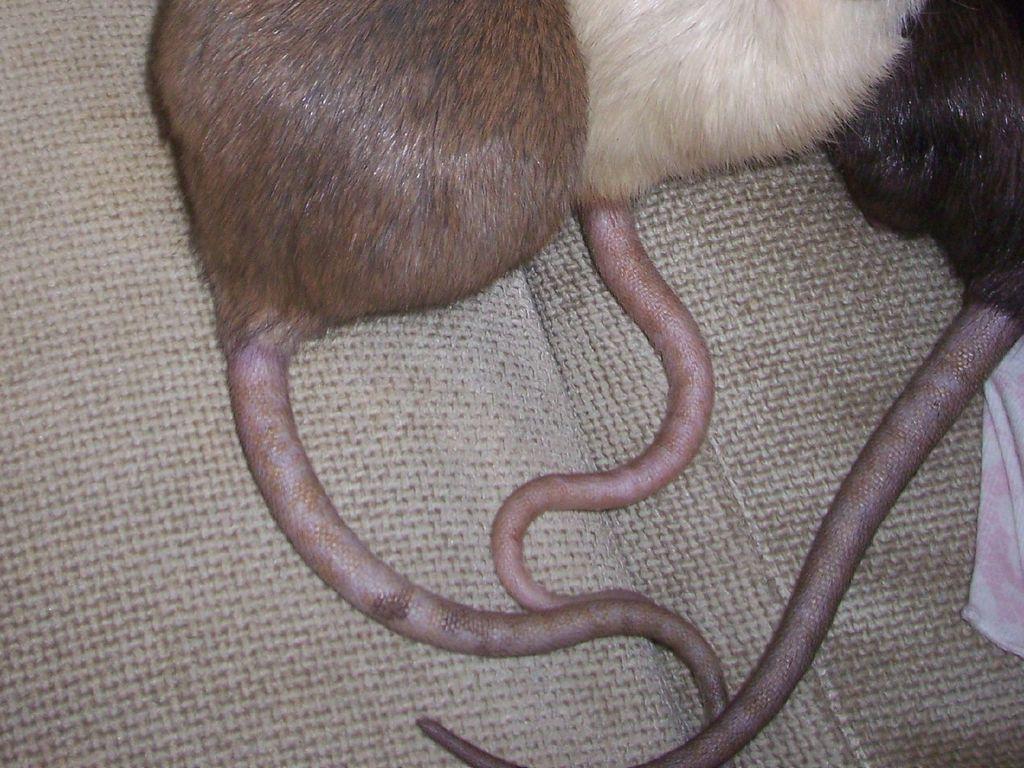Could you give a brief overview of what you see in this image? In this image I can see the tails of animals. These are looking like rats. On the right side there is a white color cloth. 